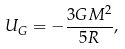Convert formula to latex. <formula><loc_0><loc_0><loc_500><loc_500>U _ { G } = - \frac { 3 G M ^ { 2 } } { 5 R } ,</formula> 